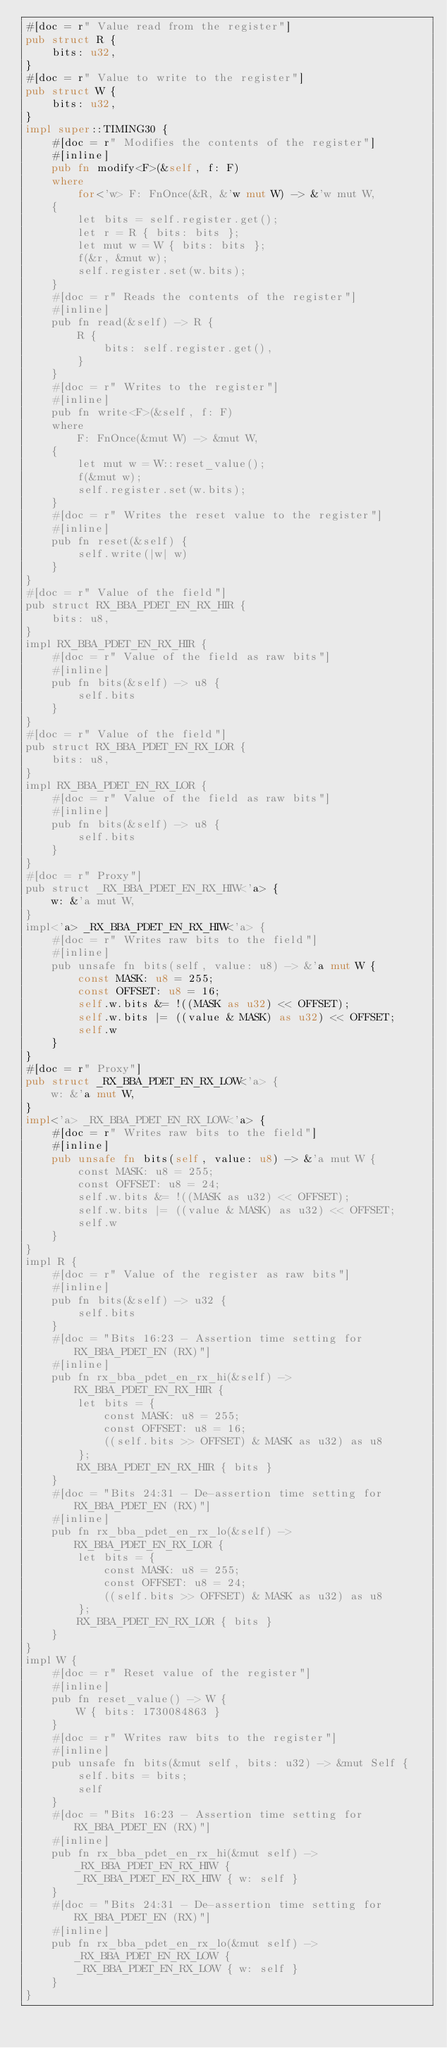<code> <loc_0><loc_0><loc_500><loc_500><_Rust_>#[doc = r" Value read from the register"]
pub struct R {
    bits: u32,
}
#[doc = r" Value to write to the register"]
pub struct W {
    bits: u32,
}
impl super::TIMING30 {
    #[doc = r" Modifies the contents of the register"]
    #[inline]
    pub fn modify<F>(&self, f: F)
    where
        for<'w> F: FnOnce(&R, &'w mut W) -> &'w mut W,
    {
        let bits = self.register.get();
        let r = R { bits: bits };
        let mut w = W { bits: bits };
        f(&r, &mut w);
        self.register.set(w.bits);
    }
    #[doc = r" Reads the contents of the register"]
    #[inline]
    pub fn read(&self) -> R {
        R {
            bits: self.register.get(),
        }
    }
    #[doc = r" Writes to the register"]
    #[inline]
    pub fn write<F>(&self, f: F)
    where
        F: FnOnce(&mut W) -> &mut W,
    {
        let mut w = W::reset_value();
        f(&mut w);
        self.register.set(w.bits);
    }
    #[doc = r" Writes the reset value to the register"]
    #[inline]
    pub fn reset(&self) {
        self.write(|w| w)
    }
}
#[doc = r" Value of the field"]
pub struct RX_BBA_PDET_EN_RX_HIR {
    bits: u8,
}
impl RX_BBA_PDET_EN_RX_HIR {
    #[doc = r" Value of the field as raw bits"]
    #[inline]
    pub fn bits(&self) -> u8 {
        self.bits
    }
}
#[doc = r" Value of the field"]
pub struct RX_BBA_PDET_EN_RX_LOR {
    bits: u8,
}
impl RX_BBA_PDET_EN_RX_LOR {
    #[doc = r" Value of the field as raw bits"]
    #[inline]
    pub fn bits(&self) -> u8 {
        self.bits
    }
}
#[doc = r" Proxy"]
pub struct _RX_BBA_PDET_EN_RX_HIW<'a> {
    w: &'a mut W,
}
impl<'a> _RX_BBA_PDET_EN_RX_HIW<'a> {
    #[doc = r" Writes raw bits to the field"]
    #[inline]
    pub unsafe fn bits(self, value: u8) -> &'a mut W {
        const MASK: u8 = 255;
        const OFFSET: u8 = 16;
        self.w.bits &= !((MASK as u32) << OFFSET);
        self.w.bits |= ((value & MASK) as u32) << OFFSET;
        self.w
    }
}
#[doc = r" Proxy"]
pub struct _RX_BBA_PDET_EN_RX_LOW<'a> {
    w: &'a mut W,
}
impl<'a> _RX_BBA_PDET_EN_RX_LOW<'a> {
    #[doc = r" Writes raw bits to the field"]
    #[inline]
    pub unsafe fn bits(self, value: u8) -> &'a mut W {
        const MASK: u8 = 255;
        const OFFSET: u8 = 24;
        self.w.bits &= !((MASK as u32) << OFFSET);
        self.w.bits |= ((value & MASK) as u32) << OFFSET;
        self.w
    }
}
impl R {
    #[doc = r" Value of the register as raw bits"]
    #[inline]
    pub fn bits(&self) -> u32 {
        self.bits
    }
    #[doc = "Bits 16:23 - Assertion time setting for RX_BBA_PDET_EN (RX)"]
    #[inline]
    pub fn rx_bba_pdet_en_rx_hi(&self) -> RX_BBA_PDET_EN_RX_HIR {
        let bits = {
            const MASK: u8 = 255;
            const OFFSET: u8 = 16;
            ((self.bits >> OFFSET) & MASK as u32) as u8
        };
        RX_BBA_PDET_EN_RX_HIR { bits }
    }
    #[doc = "Bits 24:31 - De-assertion time setting for RX_BBA_PDET_EN (RX)"]
    #[inline]
    pub fn rx_bba_pdet_en_rx_lo(&self) -> RX_BBA_PDET_EN_RX_LOR {
        let bits = {
            const MASK: u8 = 255;
            const OFFSET: u8 = 24;
            ((self.bits >> OFFSET) & MASK as u32) as u8
        };
        RX_BBA_PDET_EN_RX_LOR { bits }
    }
}
impl W {
    #[doc = r" Reset value of the register"]
    #[inline]
    pub fn reset_value() -> W {
        W { bits: 1730084863 }
    }
    #[doc = r" Writes raw bits to the register"]
    #[inline]
    pub unsafe fn bits(&mut self, bits: u32) -> &mut Self {
        self.bits = bits;
        self
    }
    #[doc = "Bits 16:23 - Assertion time setting for RX_BBA_PDET_EN (RX)"]
    #[inline]
    pub fn rx_bba_pdet_en_rx_hi(&mut self) -> _RX_BBA_PDET_EN_RX_HIW {
        _RX_BBA_PDET_EN_RX_HIW { w: self }
    }
    #[doc = "Bits 24:31 - De-assertion time setting for RX_BBA_PDET_EN (RX)"]
    #[inline]
    pub fn rx_bba_pdet_en_rx_lo(&mut self) -> _RX_BBA_PDET_EN_RX_LOW {
        _RX_BBA_PDET_EN_RX_LOW { w: self }
    }
}
</code> 